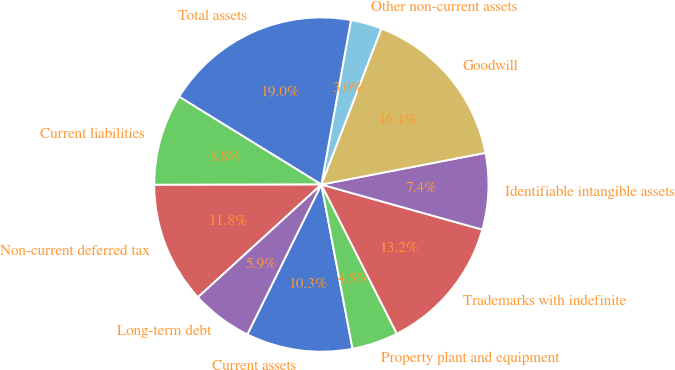Convert chart to OTSL. <chart><loc_0><loc_0><loc_500><loc_500><pie_chart><fcel>Current assets<fcel>Property plant and equipment<fcel>Trademarks with indefinite<fcel>Identifiable intangible assets<fcel>Goodwill<fcel>Other non-current assets<fcel>Total assets<fcel>Current liabilities<fcel>Non-current deferred tax<fcel>Long-term debt<nl><fcel>10.29%<fcel>4.47%<fcel>13.2%<fcel>7.38%<fcel>16.12%<fcel>3.01%<fcel>19.03%<fcel>8.83%<fcel>11.75%<fcel>5.92%<nl></chart> 